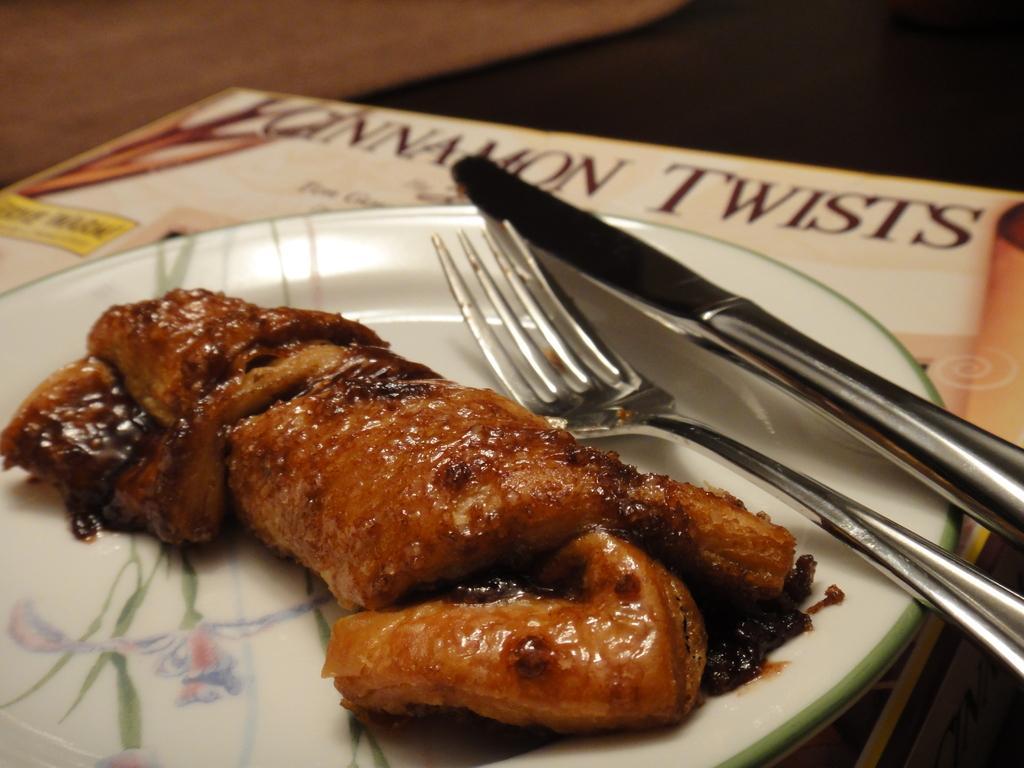Could you give a brief overview of what you see in this image? In this image I can see a white colour plate and in it I can see the brown colour food. I can also see a fork, a knife and under the plate I can see a board. I can also see something is written on the board. 